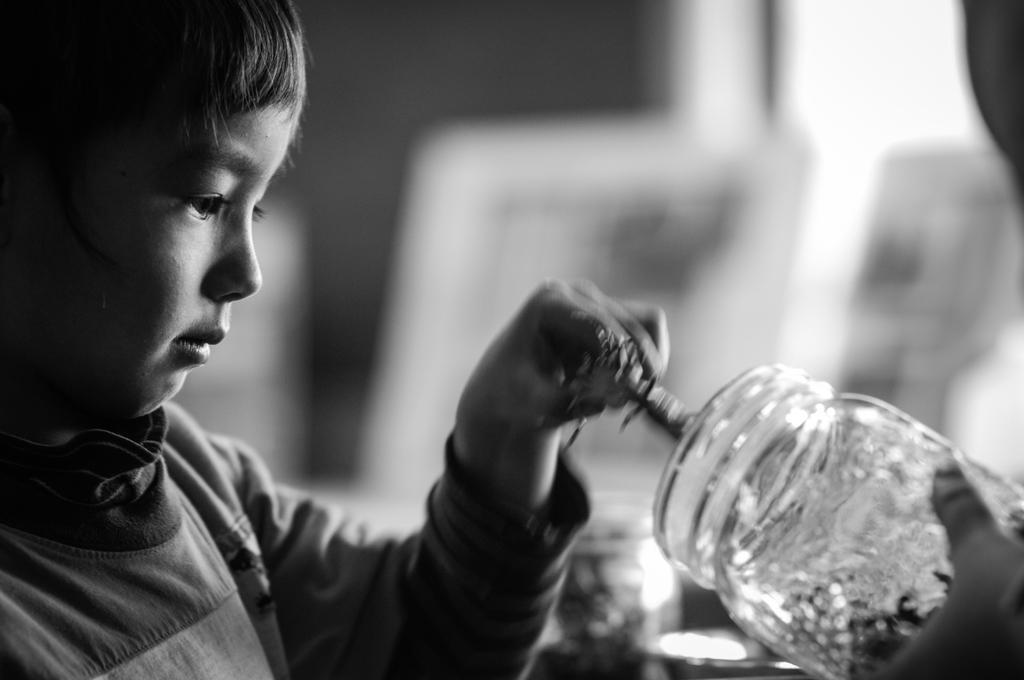In one or two sentences, can you explain what this image depicts? In this picture we can see a kid is holding a glass bottle in the front, there is a blurry background, it is a black and white image. 